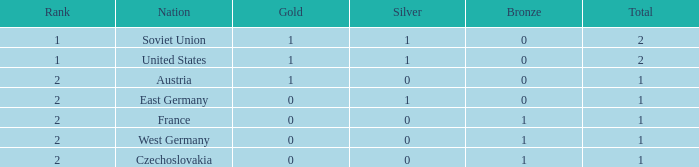How many bronze medals does west germany have, considering it is ranked 2nd and has less than 1 medal in total? 0.0. 